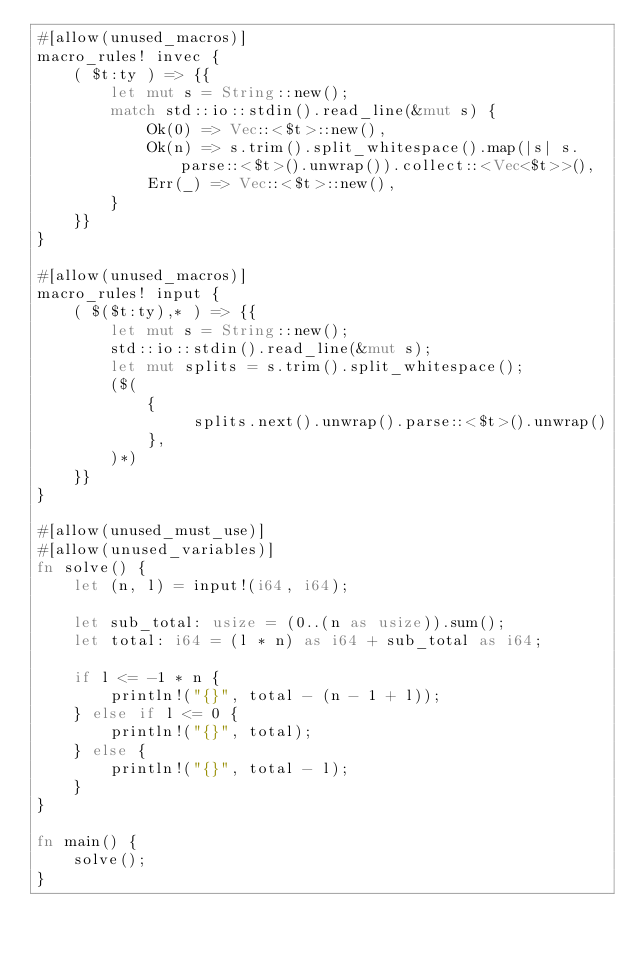<code> <loc_0><loc_0><loc_500><loc_500><_Rust_>#[allow(unused_macros)]
macro_rules! invec {
    ( $t:ty ) => {{
        let mut s = String::new();
        match std::io::stdin().read_line(&mut s) {
            Ok(0) => Vec::<$t>::new(),
            Ok(n) => s.trim().split_whitespace().map(|s| s.parse::<$t>().unwrap()).collect::<Vec<$t>>(),
            Err(_) => Vec::<$t>::new(),
        }
    }}
}

#[allow(unused_macros)]
macro_rules! input {
    ( $($t:ty),* ) => {{
        let mut s = String::new();
        std::io::stdin().read_line(&mut s);
        let mut splits = s.trim().split_whitespace();
        ($(
            {
                 splits.next().unwrap().parse::<$t>().unwrap()
            },
        )*)
    }}
}

#[allow(unused_must_use)]
#[allow(unused_variables)]
fn solve() {
    let (n, l) = input!(i64, i64);

    let sub_total: usize = (0..(n as usize)).sum();
    let total: i64 = (l * n) as i64 + sub_total as i64;

    if l <= -1 * n {
        println!("{}", total - (n - 1 + l));
    } else if l <= 0 {
        println!("{}", total);
    } else {
        println!("{}", total - l);
    }
}

fn main() {
    solve();
}
</code> 